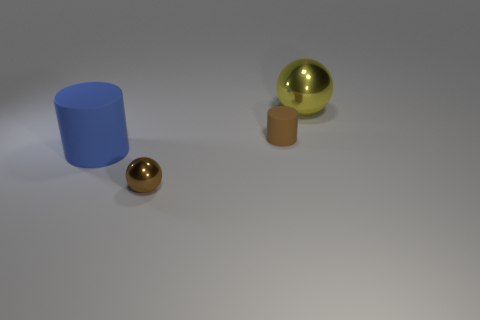Add 1 gray cylinders. How many objects exist? 5 Subtract all large blue metallic objects. Subtract all brown metal spheres. How many objects are left? 3 Add 1 small rubber objects. How many small rubber objects are left? 2 Add 4 big purple rubber cylinders. How many big purple rubber cylinders exist? 4 Subtract 0 green spheres. How many objects are left? 4 